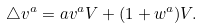Convert formula to latex. <formula><loc_0><loc_0><loc_500><loc_500>\triangle v ^ { a } = a v ^ { a } V + ( 1 + w ^ { a } ) V .</formula> 